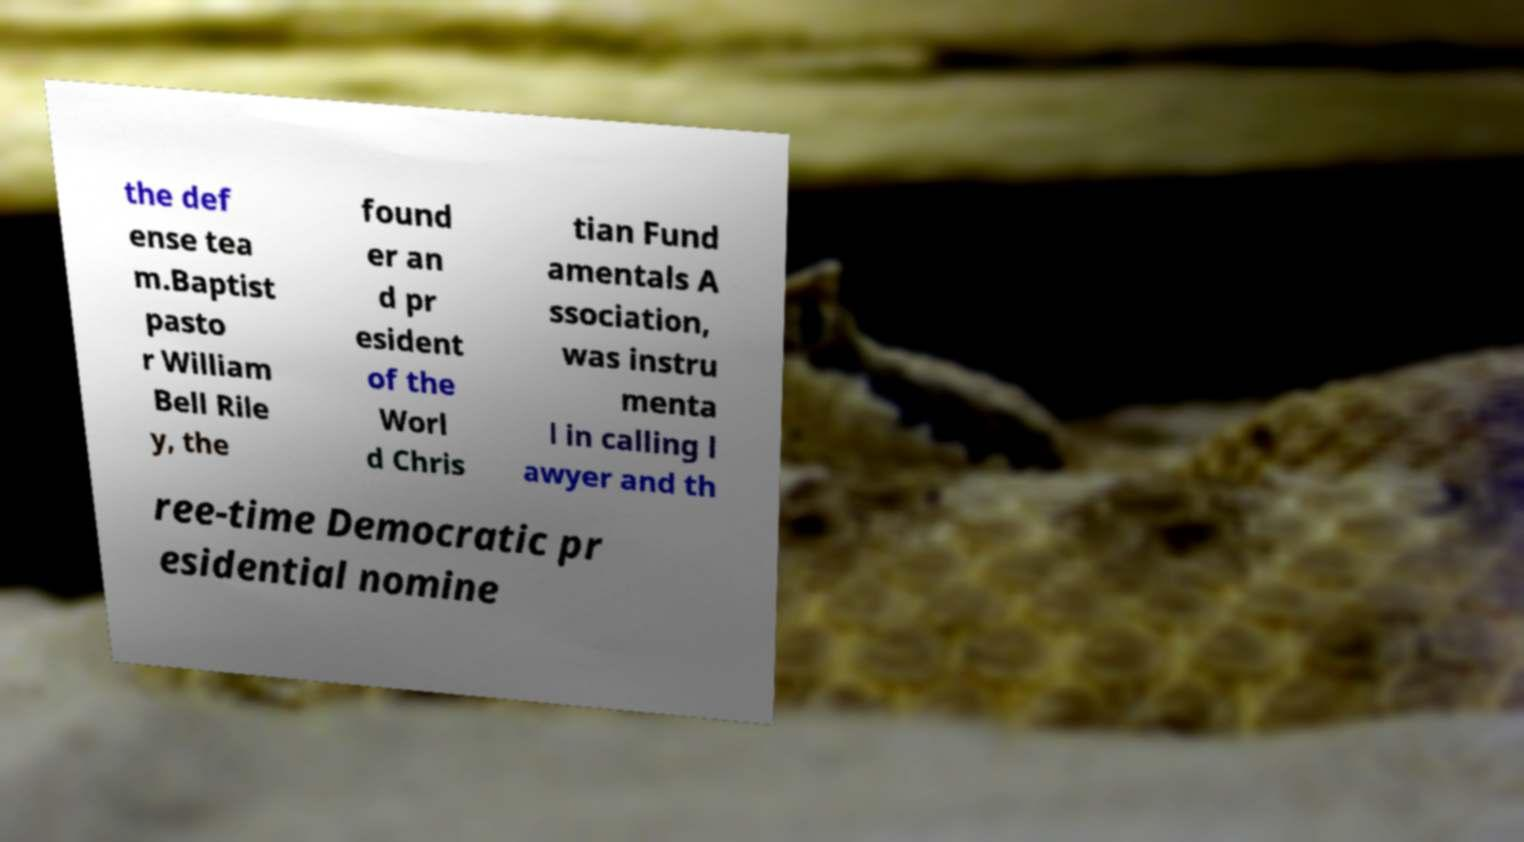For documentation purposes, I need the text within this image transcribed. Could you provide that? the def ense tea m.Baptist pasto r William Bell Rile y, the found er an d pr esident of the Worl d Chris tian Fund amentals A ssociation, was instru menta l in calling l awyer and th ree-time Democratic pr esidential nomine 